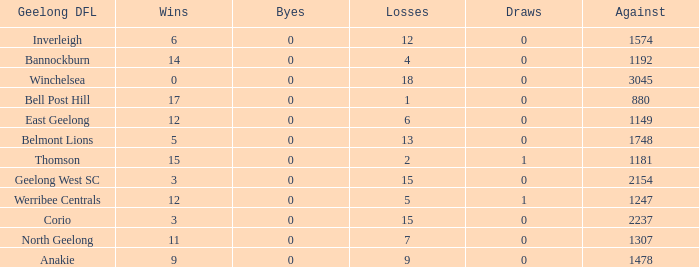What is the lowest number of wins where the byes are less than 0? None. 